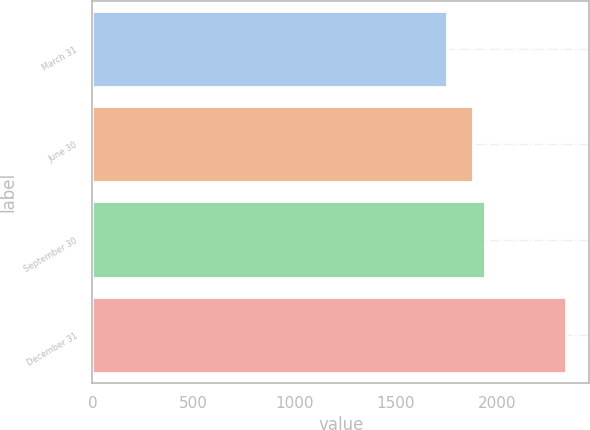<chart> <loc_0><loc_0><loc_500><loc_500><bar_chart><fcel>March 31<fcel>June 30<fcel>September 30<fcel>December 31<nl><fcel>1753.9<fcel>1884.9<fcel>1943.61<fcel>2341<nl></chart> 